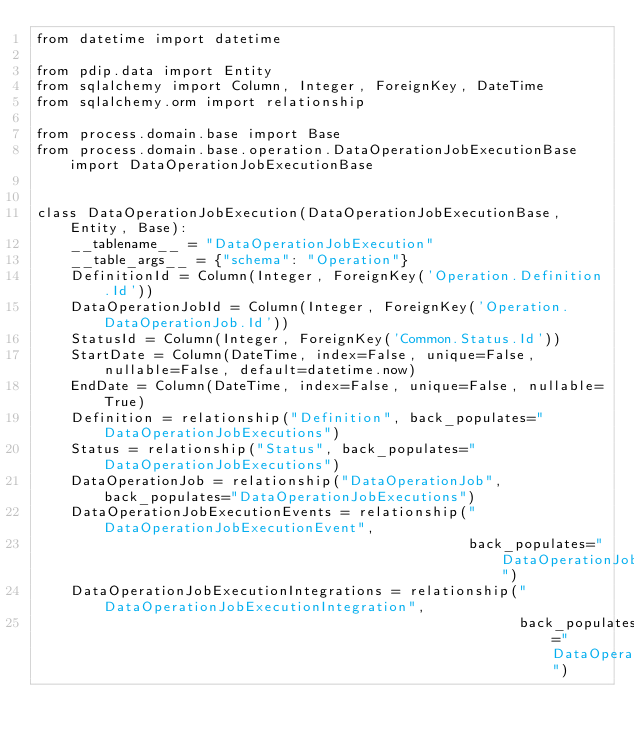<code> <loc_0><loc_0><loc_500><loc_500><_Python_>from datetime import datetime

from pdip.data import Entity
from sqlalchemy import Column, Integer, ForeignKey, DateTime
from sqlalchemy.orm import relationship

from process.domain.base import Base
from process.domain.base.operation.DataOperationJobExecutionBase import DataOperationJobExecutionBase


class DataOperationJobExecution(DataOperationJobExecutionBase, Entity, Base):
    __tablename__ = "DataOperationJobExecution"
    __table_args__ = {"schema": "Operation"}
    DefinitionId = Column(Integer, ForeignKey('Operation.Definition.Id'))
    DataOperationJobId = Column(Integer, ForeignKey('Operation.DataOperationJob.Id'))
    StatusId = Column(Integer, ForeignKey('Common.Status.Id'))
    StartDate = Column(DateTime, index=False, unique=False, nullable=False, default=datetime.now)
    EndDate = Column(DateTime, index=False, unique=False, nullable=True)
    Definition = relationship("Definition", back_populates="DataOperationJobExecutions")
    Status = relationship("Status", back_populates="DataOperationJobExecutions")
    DataOperationJob = relationship("DataOperationJob", back_populates="DataOperationJobExecutions")
    DataOperationJobExecutionEvents = relationship("DataOperationJobExecutionEvent",
                                                   back_populates="DataOperationJobExecution")
    DataOperationJobExecutionIntegrations = relationship("DataOperationJobExecutionIntegration",
                                                         back_populates="DataOperationJobExecution")
</code> 